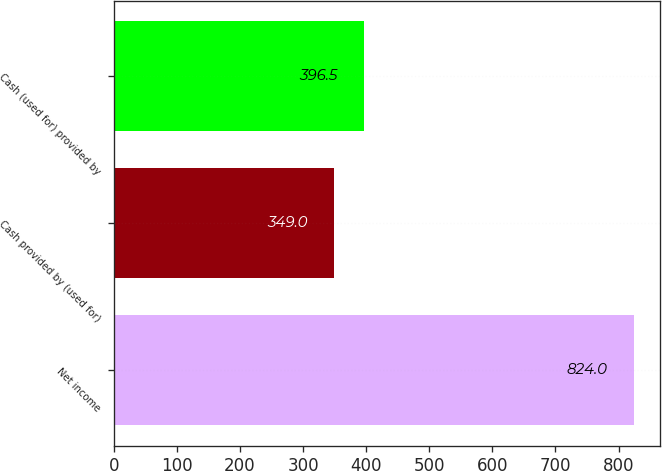Convert chart to OTSL. <chart><loc_0><loc_0><loc_500><loc_500><bar_chart><fcel>Net income<fcel>Cash provided by (used for)<fcel>Cash (used for) provided by<nl><fcel>824<fcel>349<fcel>396.5<nl></chart> 